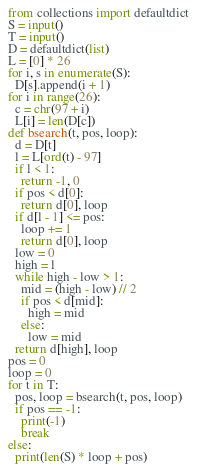Convert code to text. <code><loc_0><loc_0><loc_500><loc_500><_Python_>from collections import defaultdict
S = input()
T = input()
D = defaultdict(list)
L = [0] * 26
for i, s in enumerate(S):
  D[s].append(i + 1)
for i in range(26):
  c = chr(97 + i)
  L[i] = len(D[c])
def bsearch(t, pos, loop):
  d = D[t]
  l = L[ord(t) - 97]
  if l < 1:
    return -1, 0
  if pos < d[0]:
    return d[0], loop
  if d[l - 1] <= pos:
    loop += 1
    return d[0], loop
  low = 0
  high = l
  while high - low > 1:
    mid = (high - low) // 2
    if pos < d[mid]:
      high = mid
    else:
      low = mid
  return d[high], loop
pos = 0
loop = 0
for t in T:
  pos, loop = bsearch(t, pos, loop)
  if pos == -1:
    print(-1)
    break
else:
  print(len(S) * loop + pos)</code> 